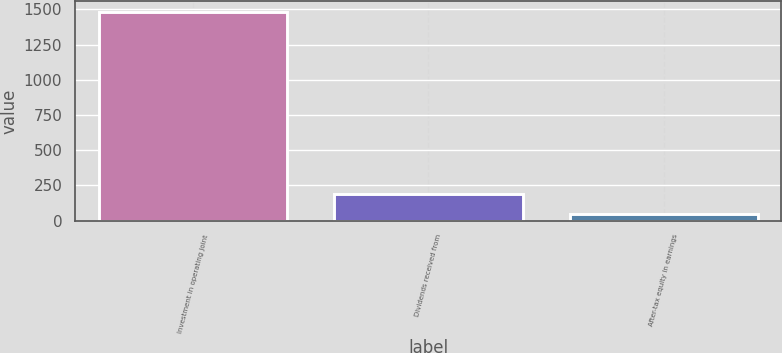Convert chart. <chart><loc_0><loc_0><loc_500><loc_500><bar_chart><fcel>Investment in operating joint<fcel>Dividends received from<fcel>After-tax equity in earnings<nl><fcel>1483<fcel>192.4<fcel>49<nl></chart> 